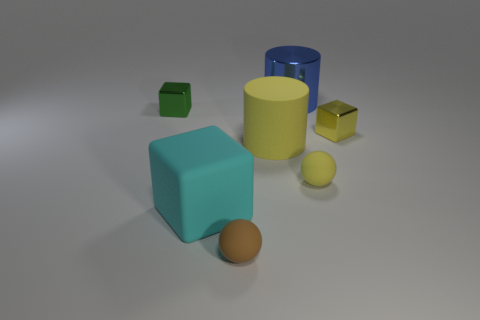Do the matte thing that is in front of the big cyan cube and the big metal object have the same shape?
Your response must be concise. No. What number of things are large blue cylinders or spheres on the right side of the blue shiny cylinder?
Ensure brevity in your answer.  2. Are the cylinder that is behind the big yellow rubber object and the tiny green cube made of the same material?
Your answer should be compact. Yes. There is a large object in front of the rubber sphere on the right side of the small brown ball; what is its material?
Ensure brevity in your answer.  Rubber. Are there more big things in front of the small green cube than yellow rubber spheres that are to the right of the blue metal cylinder?
Your answer should be very brief. Yes. The cyan block is what size?
Make the answer very short. Large. Do the small shiny block that is right of the small yellow sphere and the rubber cylinder have the same color?
Give a very brief answer. Yes. There is a tiny rubber ball in front of the cyan rubber cube; are there any brown rubber things that are on the right side of it?
Provide a succinct answer. No. Is the number of tiny green objects that are behind the large blue metallic cylinder less than the number of shiny things that are to the right of the tiny yellow rubber thing?
Your answer should be very brief. Yes. How big is the metallic block that is right of the small metallic cube that is behind the shiny cube on the right side of the big matte cylinder?
Keep it short and to the point. Small. 